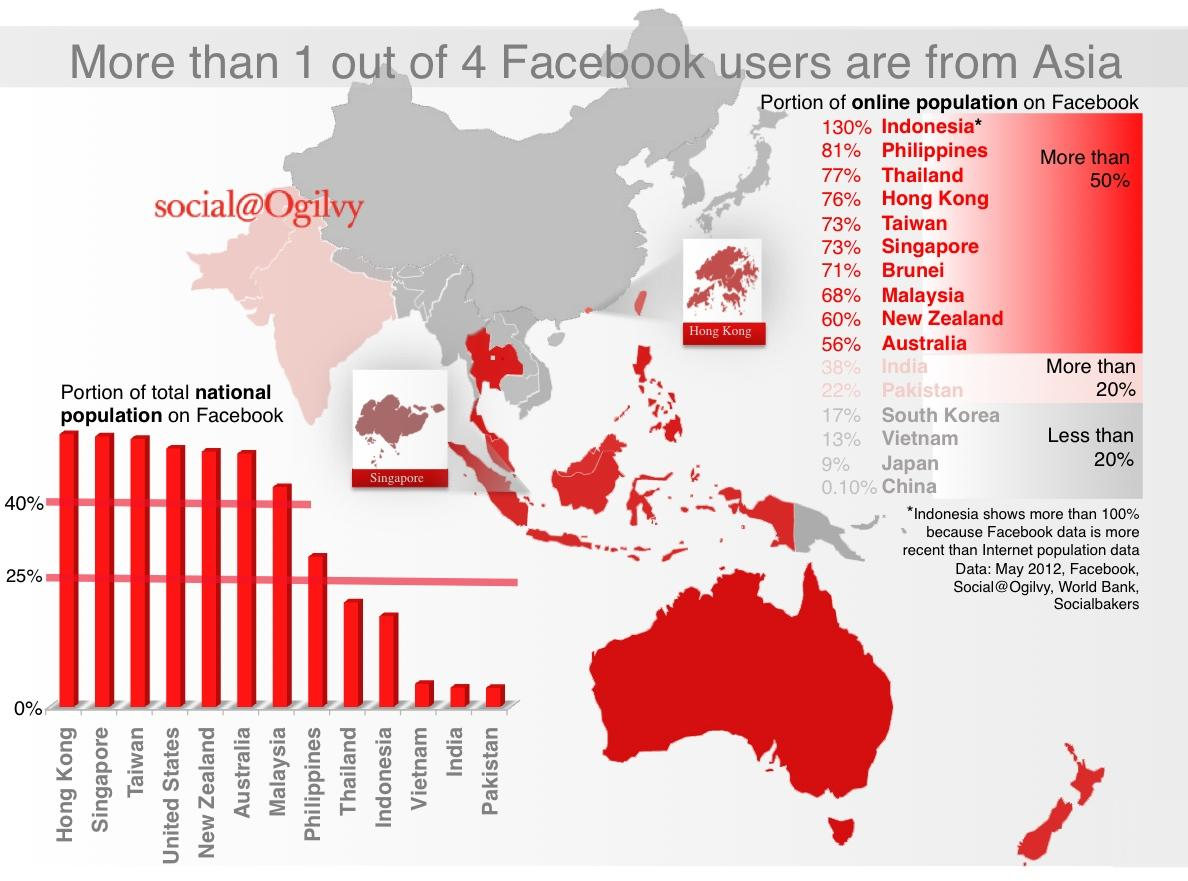List a handful of essential elements in this visual. Approximately 4 countries have less than 20% of their online population on Facebook. It is estimated that 10 countries have more than 50% of their online population active on Facebook. It is estimated that approximately 7 countries have over 40% of their national population on Facebook. As of 2021, approximately 5 countries have a population ranging from 0 to 25% on Facebook. According to recent data, only two countries have more than 20% of their online population on Facebook. 